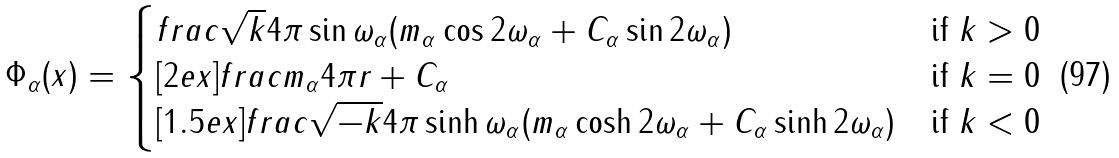Convert formula to latex. <formula><loc_0><loc_0><loc_500><loc_500>\Phi _ { \alpha } ( { x } ) = \begin{cases} f r a c { \sqrt { k } } { 4 \pi \sin \omega _ { \alpha } } ( m _ { \alpha } \cos 2 \omega _ { \alpha } + C _ { \alpha } \sin 2 \omega _ { \alpha } ) & \text {if $k>0$} \\ [ 2 e x ] f r a c { m _ { \alpha } } { 4 \pi r } + C _ { \alpha } & \text {if $k=0$} \\ [ 1 . 5 e x ] f r a c { \sqrt { - k } } { 4 \pi \sinh \omega _ { \alpha } } ( m _ { \alpha } \cosh 2 \omega _ { \alpha } + C _ { \alpha } \sinh 2 \omega _ { \alpha } ) & \text {if $k<0$} \end{cases}</formula> 